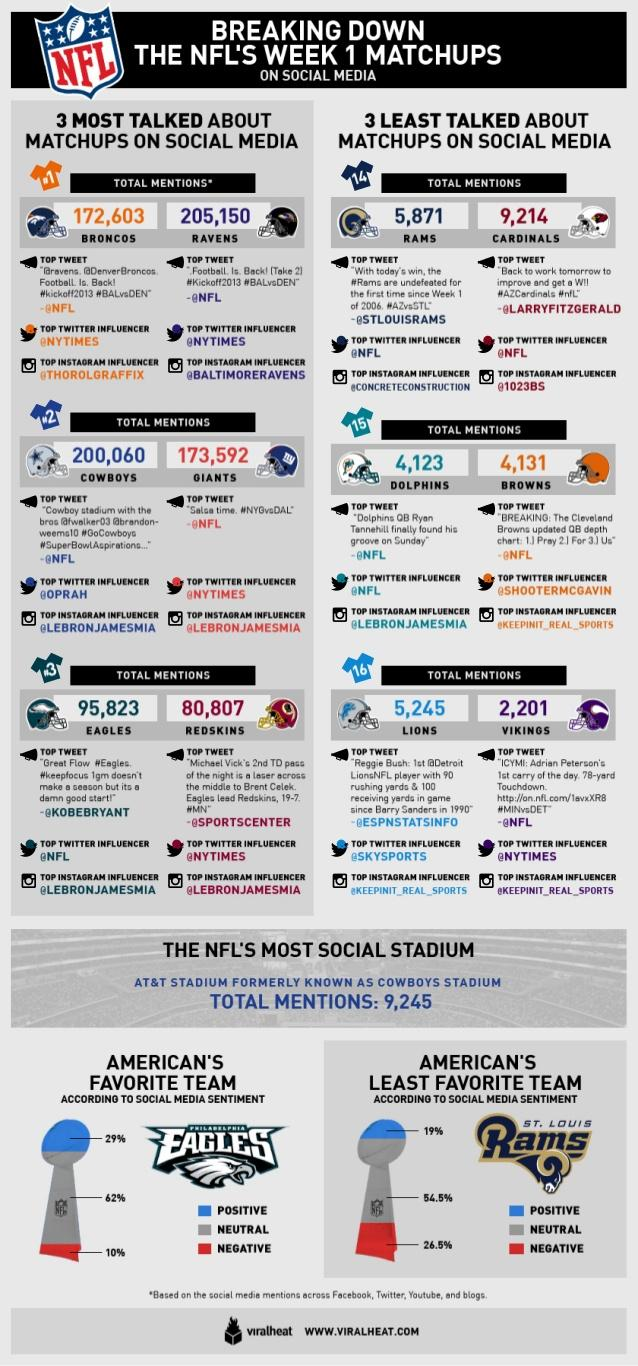Identify some key points in this picture. The team that has been paired with the Detroit Lions, Redskins, Minnesota Vikings, and Philadelphia Eagles is the Minnesota Vikings. The team with the most mentions on social media is the Ravens. The rate of neutral social media sentiment received by Team Eagles is 62%. The lowest count of mentions on social media is 2,201. The Denver Broncos had the highest number of mentions on social media among the NFL teams mentioned. 